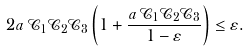Convert formula to latex. <formula><loc_0><loc_0><loc_500><loc_500>2 a \, { \mathcal { C } } _ { 1 } { \mathcal { C } } _ { 2 } { \mathcal { C } } _ { 3 } \left ( 1 + \frac { a \, { \mathcal { C } } _ { 1 } { \mathcal { C } } _ { 2 } { \mathcal { C } } _ { 3 } } { 1 - \varepsilon } \right ) \leq \varepsilon .</formula> 